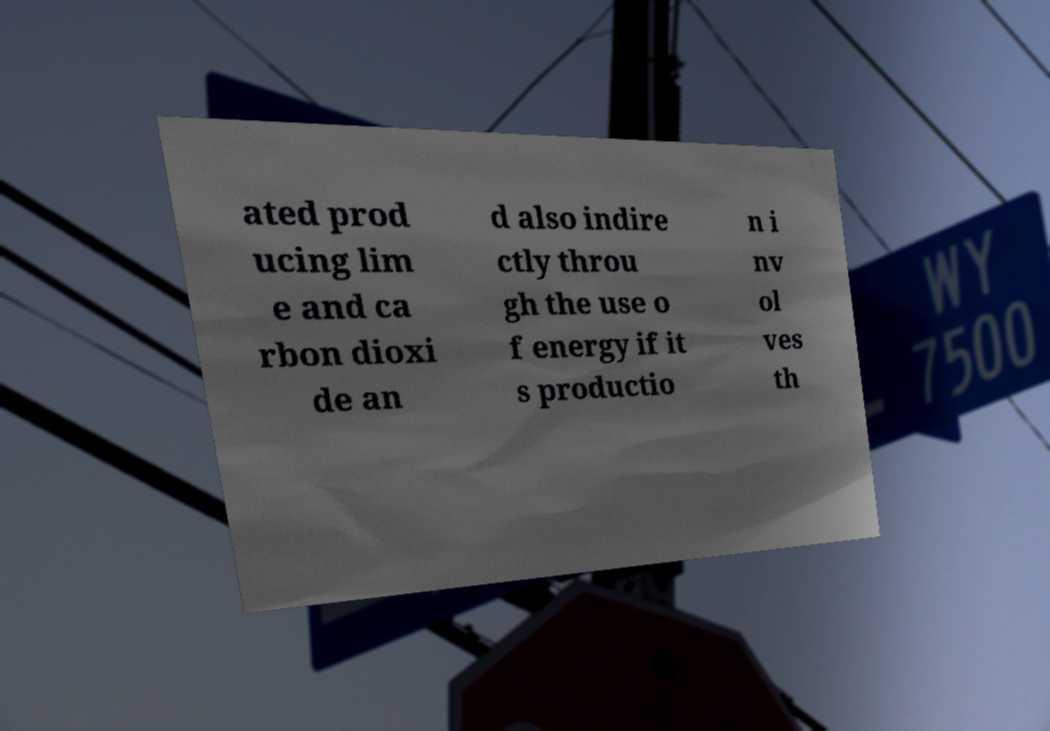Can you read and provide the text displayed in the image?This photo seems to have some interesting text. Can you extract and type it out for me? ated prod ucing lim e and ca rbon dioxi de an d also indire ctly throu gh the use o f energy if it s productio n i nv ol ves th 